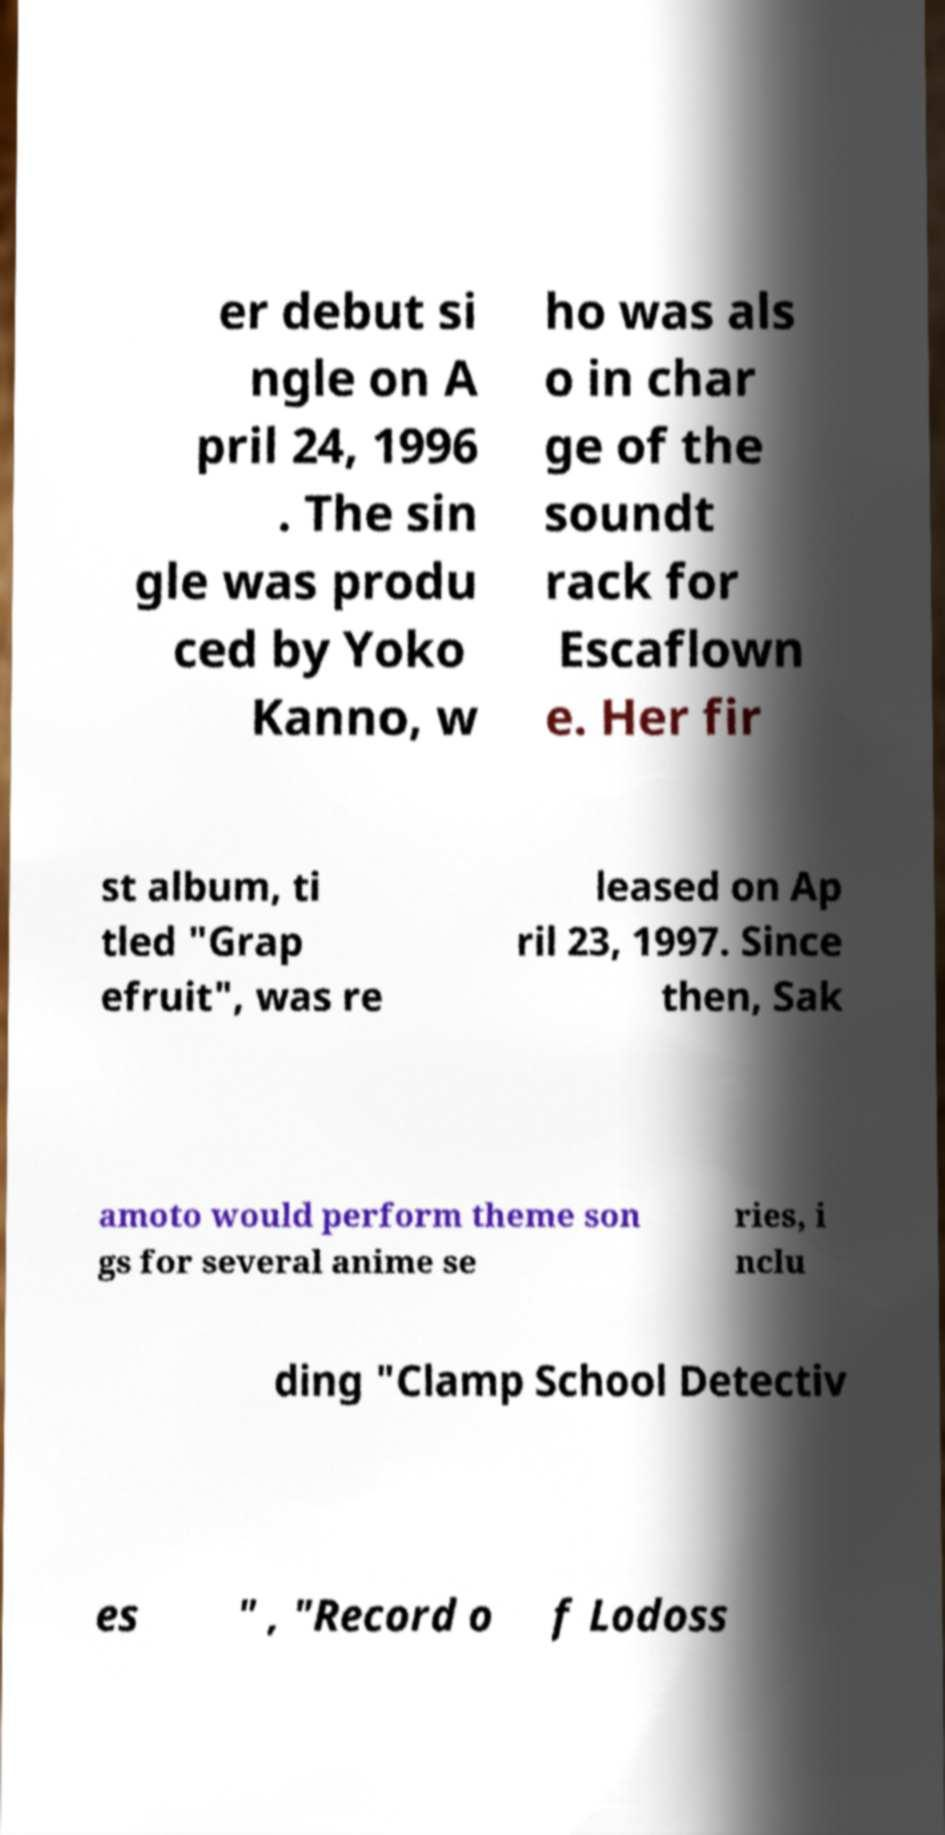Please read and relay the text visible in this image. What does it say? er debut si ngle on A pril 24, 1996 . The sin gle was produ ced by Yoko Kanno, w ho was als o in char ge of the soundt rack for Escaflown e. Her fir st album, ti tled "Grap efruit", was re leased on Ap ril 23, 1997. Since then, Sak amoto would perform theme son gs for several anime se ries, i nclu ding "Clamp School Detectiv es " , "Record o f Lodoss 